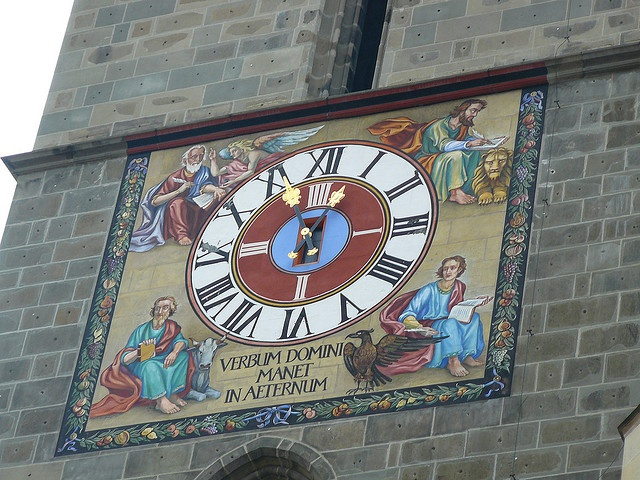Describe the objects in this image and their specific colors. I can see clock in white, lightgray, brown, gray, and black tones, people in white, gray, darkgray, and tan tones, people in white, gray, and darkgray tones, people in white, lightblue, gray, and darkgray tones, and people in white, teal, gray, darkgray, and tan tones in this image. 